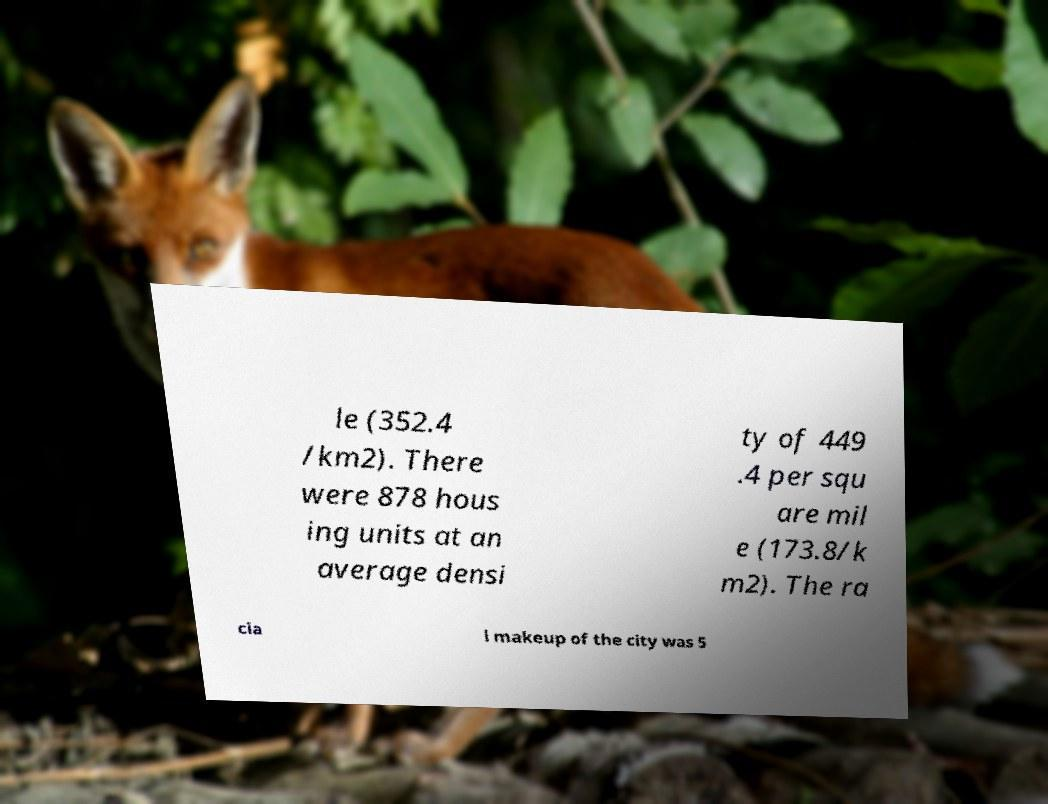Please read and relay the text visible in this image. What does it say? le (352.4 /km2). There were 878 hous ing units at an average densi ty of 449 .4 per squ are mil e (173.8/k m2). The ra cia l makeup of the city was 5 